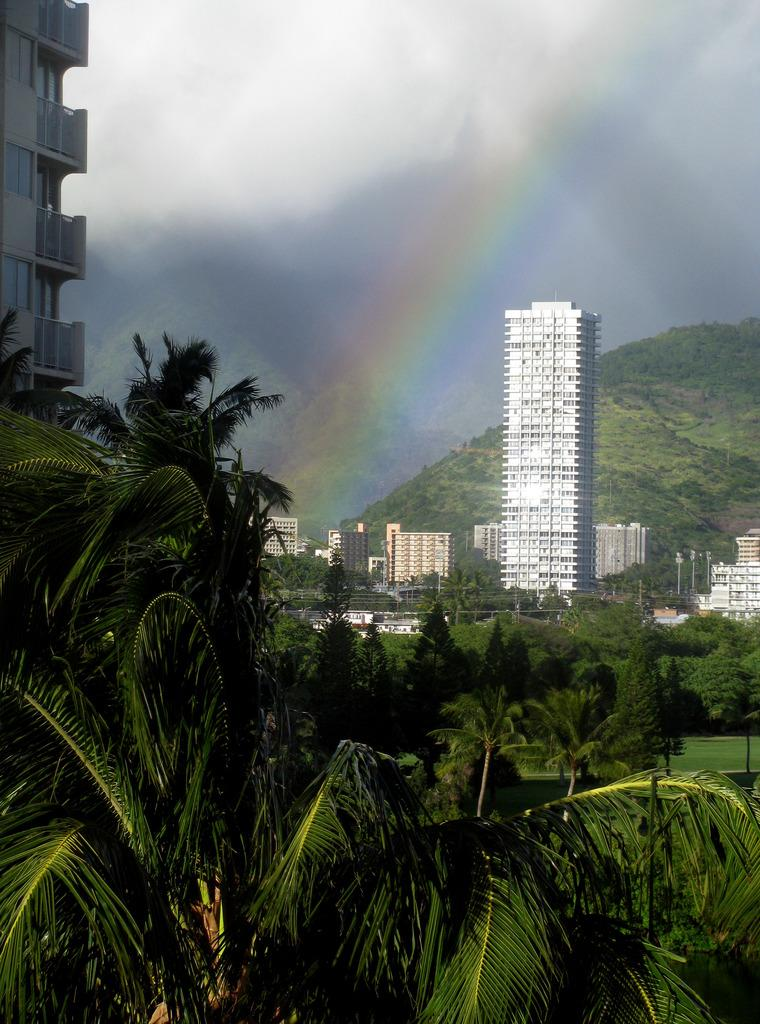What type of vegetation can be seen in the image? There are trees in the image. What is the color of the trees? The trees are green in color. What else is present in the image besides trees? There are buildings in the image. What can be seen in the background of the image? There is a rainbow visible in the background. How would you describe the color of the sky in the image? The sky is white and gray in color. Where is the turkey located in the image? There is no turkey present in the image. What type of rock can be seen in the image? There is no rock visible in the image. 